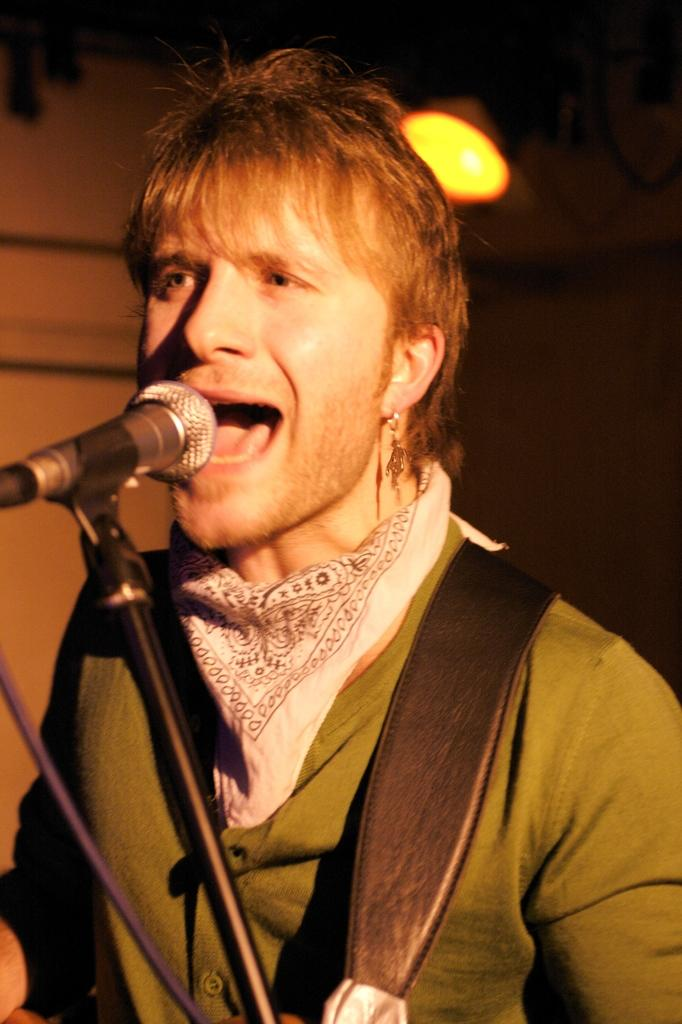What is the person in the image doing? The person in the image is singing. What is the person using to amplify their voice? There is a microphone in the image, which is on a stand. What can be seen in the background of the image? There is a wall and light visible in the background of the image. Can you see a giraffe in the image? No, there is no giraffe present in the image. What type of soda is the person drinking while singing in the image? There is no soda visible in the image, and the person is not shown drinking anything. 